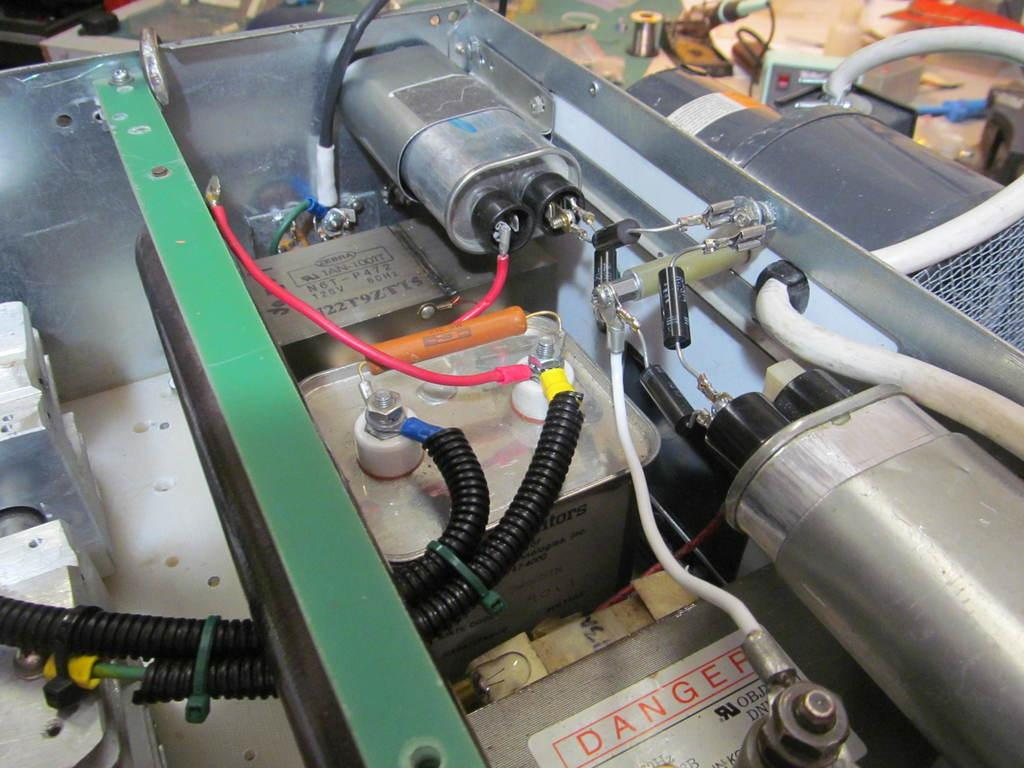What type of objects are present in the image? There is equipment in the image. Can you describe any specific features of the equipment? The equipment has cables and nuts. What type of steel is used to construct the authority's building in the image? There is no building or authority mentioned in the image, and therefore no such information can be provided. How many nails can be seen holding the equipment together in the image? There is no mention of nails being used to hold the equipment together in the image. 